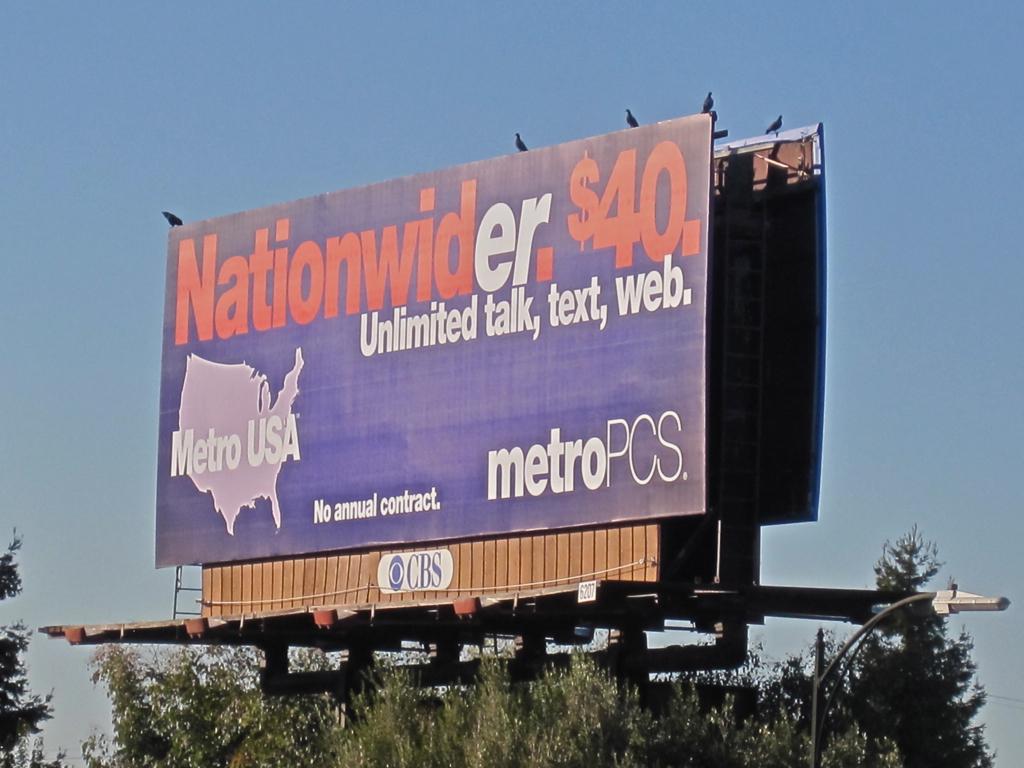In order to get the advertised price, is a contract required?
Keep it short and to the point. No. 